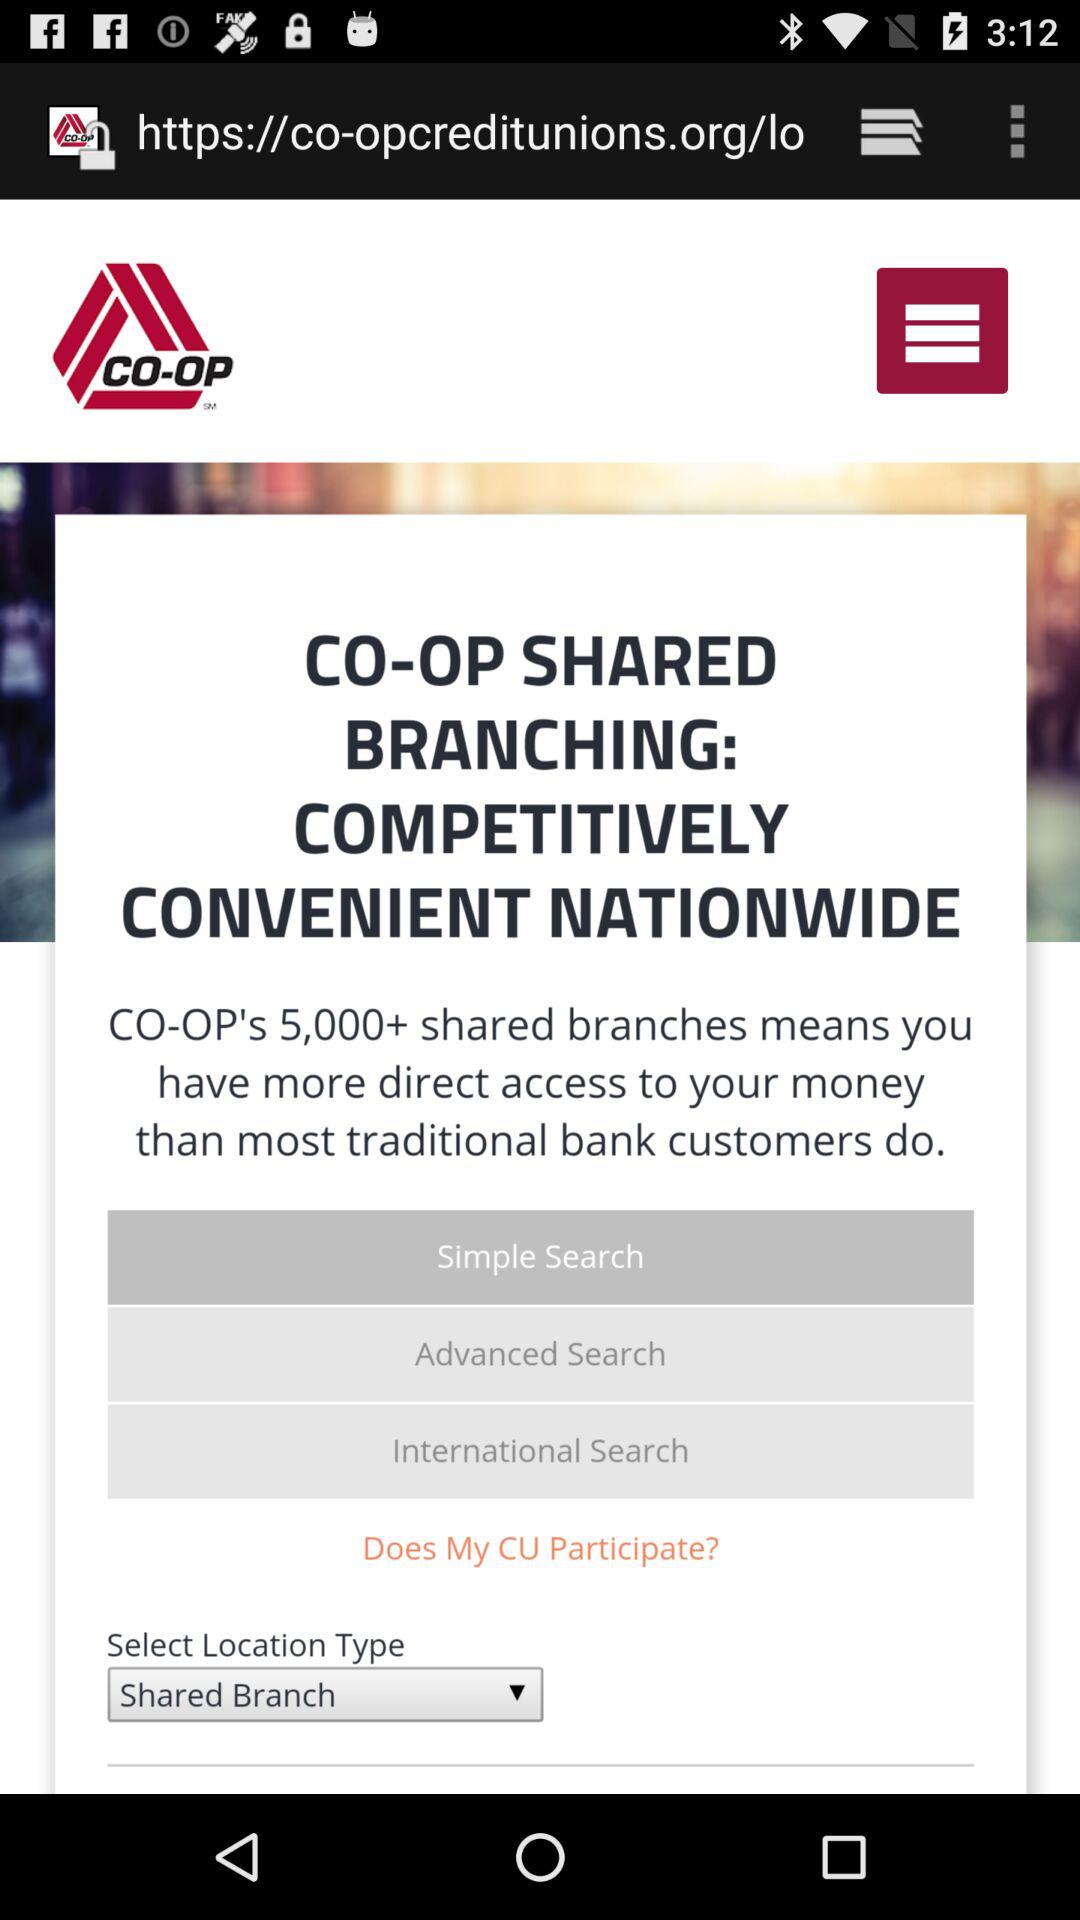Does the user's CU participate?
When the provided information is insufficient, respond with <no answer>. <no answer> 